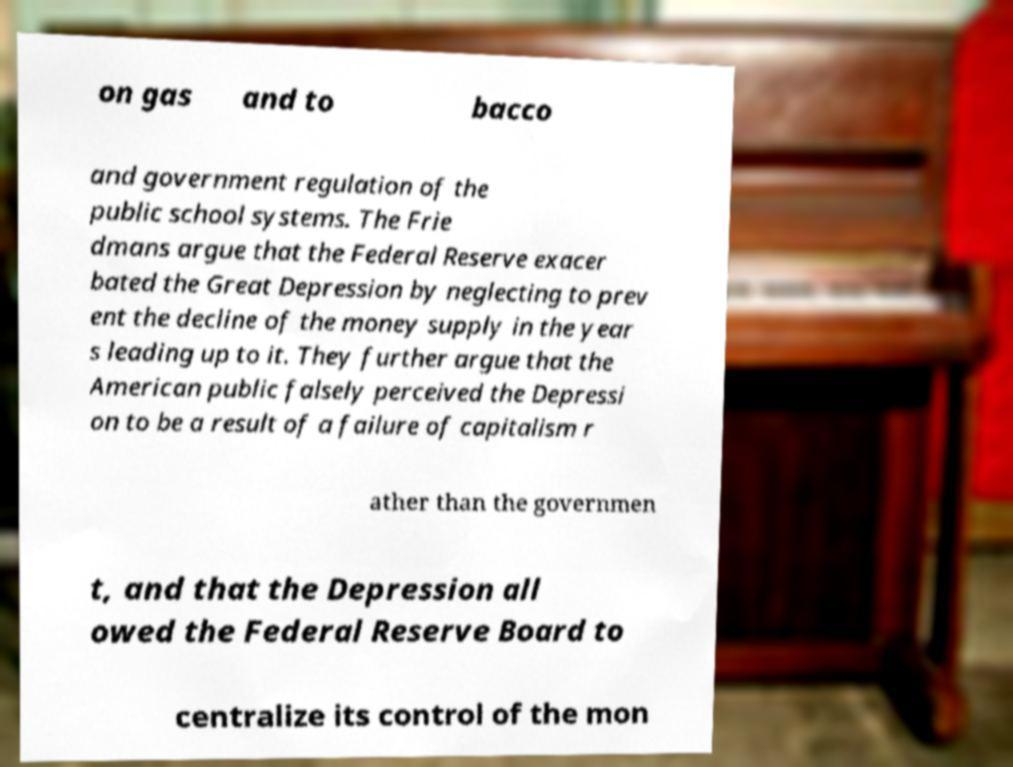Please read and relay the text visible in this image. What does it say? on gas and to bacco and government regulation of the public school systems. The Frie dmans argue that the Federal Reserve exacer bated the Great Depression by neglecting to prev ent the decline of the money supply in the year s leading up to it. They further argue that the American public falsely perceived the Depressi on to be a result of a failure of capitalism r ather than the governmen t, and that the Depression all owed the Federal Reserve Board to centralize its control of the mon 